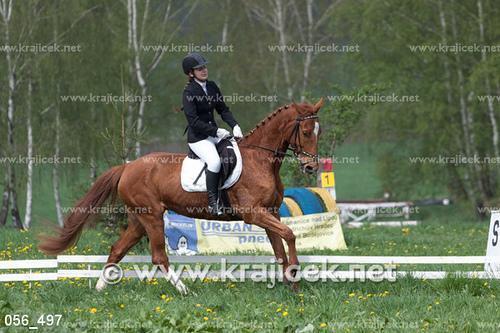How many people?
Give a very brief answer. 1. 